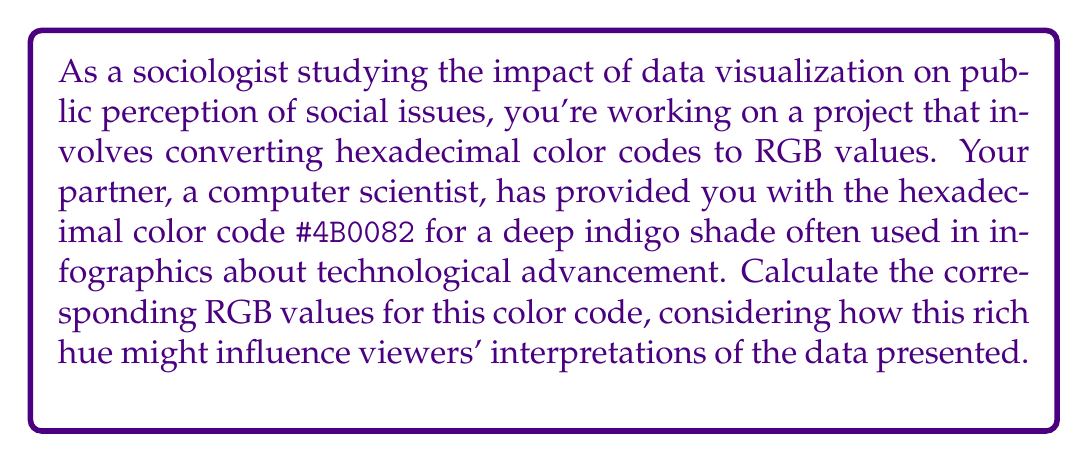Solve this math problem. To convert a hexadecimal color code to RGB values, we follow these steps:

1) The hexadecimal code #4B0082 consists of three pairs of characters: 4B, 00, and 82.

2) Each pair represents a color channel: Red (4B), Green (00), and Blue (82).

3) We need to convert each pair from hexadecimal to decimal:

   For Red (4B):
   $4B_{16} = 4 \times 16^1 + 11 \times 16^0 = 64 + 11 = 75_{10}$

   For Green (00):
   $00_{16} = 0 \times 16^1 + 0 \times 16^0 = 0_{10}$

   For Blue (82):
   $82_{16} = 8 \times 16^1 + 2 \times 16^0 = 128 + 2 = 130_{10}$

4) The resulting RGB values are (75, 0, 130).

This deep indigo color, with its strong blue component and absence of green, might evoke associations with technology and innovation in data visualizations, potentially influencing viewers' perceptions of the presented information on technological advancement.
Answer: (75, 0, 130) 